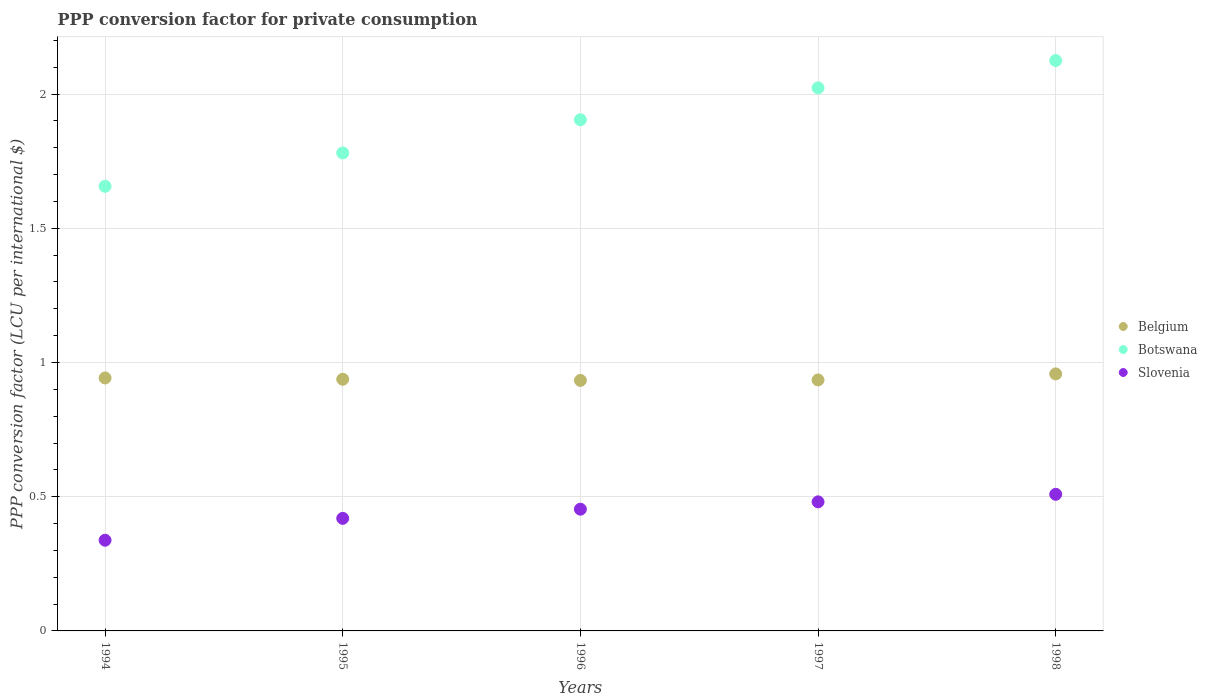How many different coloured dotlines are there?
Provide a succinct answer. 3. What is the PPP conversion factor for private consumption in Belgium in 1995?
Give a very brief answer. 0.94. Across all years, what is the maximum PPP conversion factor for private consumption in Slovenia?
Your answer should be very brief. 0.51. Across all years, what is the minimum PPP conversion factor for private consumption in Belgium?
Provide a succinct answer. 0.93. In which year was the PPP conversion factor for private consumption in Botswana maximum?
Your response must be concise. 1998. In which year was the PPP conversion factor for private consumption in Botswana minimum?
Ensure brevity in your answer.  1994. What is the total PPP conversion factor for private consumption in Botswana in the graph?
Offer a very short reply. 9.49. What is the difference between the PPP conversion factor for private consumption in Belgium in 1994 and that in 1997?
Your answer should be compact. 0.01. What is the difference between the PPP conversion factor for private consumption in Botswana in 1997 and the PPP conversion factor for private consumption in Slovenia in 1996?
Your answer should be very brief. 1.57. What is the average PPP conversion factor for private consumption in Slovenia per year?
Offer a terse response. 0.44. In the year 1996, what is the difference between the PPP conversion factor for private consumption in Belgium and PPP conversion factor for private consumption in Slovenia?
Keep it short and to the point. 0.48. In how many years, is the PPP conversion factor for private consumption in Belgium greater than 1.6 LCU?
Make the answer very short. 0. What is the ratio of the PPP conversion factor for private consumption in Belgium in 1995 to that in 1998?
Ensure brevity in your answer.  0.98. What is the difference between the highest and the second highest PPP conversion factor for private consumption in Botswana?
Offer a terse response. 0.1. What is the difference between the highest and the lowest PPP conversion factor for private consumption in Belgium?
Give a very brief answer. 0.02. In how many years, is the PPP conversion factor for private consumption in Belgium greater than the average PPP conversion factor for private consumption in Belgium taken over all years?
Offer a very short reply. 2. Is the sum of the PPP conversion factor for private consumption in Belgium in 1995 and 1996 greater than the maximum PPP conversion factor for private consumption in Slovenia across all years?
Make the answer very short. Yes. Is the PPP conversion factor for private consumption in Belgium strictly greater than the PPP conversion factor for private consumption in Slovenia over the years?
Your answer should be very brief. Yes. How many dotlines are there?
Keep it short and to the point. 3. What is the difference between two consecutive major ticks on the Y-axis?
Offer a terse response. 0.5. Are the values on the major ticks of Y-axis written in scientific E-notation?
Make the answer very short. No. Where does the legend appear in the graph?
Your answer should be very brief. Center right. How many legend labels are there?
Your answer should be very brief. 3. How are the legend labels stacked?
Your response must be concise. Vertical. What is the title of the graph?
Your response must be concise. PPP conversion factor for private consumption. What is the label or title of the X-axis?
Offer a very short reply. Years. What is the label or title of the Y-axis?
Keep it short and to the point. PPP conversion factor (LCU per international $). What is the PPP conversion factor (LCU per international $) in Belgium in 1994?
Provide a short and direct response. 0.94. What is the PPP conversion factor (LCU per international $) in Botswana in 1994?
Keep it short and to the point. 1.66. What is the PPP conversion factor (LCU per international $) of Slovenia in 1994?
Offer a very short reply. 0.34. What is the PPP conversion factor (LCU per international $) of Belgium in 1995?
Your response must be concise. 0.94. What is the PPP conversion factor (LCU per international $) in Botswana in 1995?
Make the answer very short. 1.78. What is the PPP conversion factor (LCU per international $) of Slovenia in 1995?
Offer a very short reply. 0.42. What is the PPP conversion factor (LCU per international $) of Belgium in 1996?
Provide a succinct answer. 0.93. What is the PPP conversion factor (LCU per international $) of Botswana in 1996?
Your answer should be compact. 1.9. What is the PPP conversion factor (LCU per international $) in Slovenia in 1996?
Give a very brief answer. 0.45. What is the PPP conversion factor (LCU per international $) of Belgium in 1997?
Offer a terse response. 0.94. What is the PPP conversion factor (LCU per international $) in Botswana in 1997?
Your answer should be compact. 2.02. What is the PPP conversion factor (LCU per international $) of Slovenia in 1997?
Your answer should be compact. 0.48. What is the PPP conversion factor (LCU per international $) in Belgium in 1998?
Give a very brief answer. 0.96. What is the PPP conversion factor (LCU per international $) of Botswana in 1998?
Offer a very short reply. 2.12. What is the PPP conversion factor (LCU per international $) of Slovenia in 1998?
Ensure brevity in your answer.  0.51. Across all years, what is the maximum PPP conversion factor (LCU per international $) of Belgium?
Offer a terse response. 0.96. Across all years, what is the maximum PPP conversion factor (LCU per international $) of Botswana?
Your answer should be very brief. 2.12. Across all years, what is the maximum PPP conversion factor (LCU per international $) of Slovenia?
Provide a succinct answer. 0.51. Across all years, what is the minimum PPP conversion factor (LCU per international $) in Belgium?
Your answer should be very brief. 0.93. Across all years, what is the minimum PPP conversion factor (LCU per international $) in Botswana?
Your answer should be very brief. 1.66. Across all years, what is the minimum PPP conversion factor (LCU per international $) in Slovenia?
Your response must be concise. 0.34. What is the total PPP conversion factor (LCU per international $) of Belgium in the graph?
Your answer should be compact. 4.71. What is the total PPP conversion factor (LCU per international $) in Botswana in the graph?
Offer a very short reply. 9.49. What is the total PPP conversion factor (LCU per international $) in Slovenia in the graph?
Provide a succinct answer. 2.2. What is the difference between the PPP conversion factor (LCU per international $) of Belgium in 1994 and that in 1995?
Provide a short and direct response. 0. What is the difference between the PPP conversion factor (LCU per international $) of Botswana in 1994 and that in 1995?
Your answer should be compact. -0.12. What is the difference between the PPP conversion factor (LCU per international $) of Slovenia in 1994 and that in 1995?
Ensure brevity in your answer.  -0.08. What is the difference between the PPP conversion factor (LCU per international $) of Belgium in 1994 and that in 1996?
Provide a short and direct response. 0.01. What is the difference between the PPP conversion factor (LCU per international $) of Botswana in 1994 and that in 1996?
Keep it short and to the point. -0.25. What is the difference between the PPP conversion factor (LCU per international $) of Slovenia in 1994 and that in 1996?
Make the answer very short. -0.12. What is the difference between the PPP conversion factor (LCU per international $) in Belgium in 1994 and that in 1997?
Keep it short and to the point. 0.01. What is the difference between the PPP conversion factor (LCU per international $) of Botswana in 1994 and that in 1997?
Your response must be concise. -0.37. What is the difference between the PPP conversion factor (LCU per international $) in Slovenia in 1994 and that in 1997?
Give a very brief answer. -0.14. What is the difference between the PPP conversion factor (LCU per international $) in Belgium in 1994 and that in 1998?
Offer a terse response. -0.02. What is the difference between the PPP conversion factor (LCU per international $) of Botswana in 1994 and that in 1998?
Offer a terse response. -0.47. What is the difference between the PPP conversion factor (LCU per international $) of Slovenia in 1994 and that in 1998?
Ensure brevity in your answer.  -0.17. What is the difference between the PPP conversion factor (LCU per international $) in Belgium in 1995 and that in 1996?
Give a very brief answer. 0. What is the difference between the PPP conversion factor (LCU per international $) in Botswana in 1995 and that in 1996?
Ensure brevity in your answer.  -0.12. What is the difference between the PPP conversion factor (LCU per international $) of Slovenia in 1995 and that in 1996?
Give a very brief answer. -0.03. What is the difference between the PPP conversion factor (LCU per international $) in Belgium in 1995 and that in 1997?
Your answer should be very brief. 0. What is the difference between the PPP conversion factor (LCU per international $) in Botswana in 1995 and that in 1997?
Offer a terse response. -0.24. What is the difference between the PPP conversion factor (LCU per international $) of Slovenia in 1995 and that in 1997?
Give a very brief answer. -0.06. What is the difference between the PPP conversion factor (LCU per international $) in Belgium in 1995 and that in 1998?
Your answer should be very brief. -0.02. What is the difference between the PPP conversion factor (LCU per international $) of Botswana in 1995 and that in 1998?
Give a very brief answer. -0.34. What is the difference between the PPP conversion factor (LCU per international $) of Slovenia in 1995 and that in 1998?
Make the answer very short. -0.09. What is the difference between the PPP conversion factor (LCU per international $) of Belgium in 1996 and that in 1997?
Make the answer very short. -0. What is the difference between the PPP conversion factor (LCU per international $) of Botswana in 1996 and that in 1997?
Your answer should be very brief. -0.12. What is the difference between the PPP conversion factor (LCU per international $) in Slovenia in 1996 and that in 1997?
Provide a succinct answer. -0.03. What is the difference between the PPP conversion factor (LCU per international $) in Belgium in 1996 and that in 1998?
Your answer should be very brief. -0.02. What is the difference between the PPP conversion factor (LCU per international $) of Botswana in 1996 and that in 1998?
Offer a very short reply. -0.22. What is the difference between the PPP conversion factor (LCU per international $) in Slovenia in 1996 and that in 1998?
Keep it short and to the point. -0.06. What is the difference between the PPP conversion factor (LCU per international $) of Belgium in 1997 and that in 1998?
Provide a succinct answer. -0.02. What is the difference between the PPP conversion factor (LCU per international $) in Botswana in 1997 and that in 1998?
Your response must be concise. -0.1. What is the difference between the PPP conversion factor (LCU per international $) of Slovenia in 1997 and that in 1998?
Your response must be concise. -0.03. What is the difference between the PPP conversion factor (LCU per international $) in Belgium in 1994 and the PPP conversion factor (LCU per international $) in Botswana in 1995?
Provide a succinct answer. -0.84. What is the difference between the PPP conversion factor (LCU per international $) in Belgium in 1994 and the PPP conversion factor (LCU per international $) in Slovenia in 1995?
Provide a short and direct response. 0.52. What is the difference between the PPP conversion factor (LCU per international $) in Botswana in 1994 and the PPP conversion factor (LCU per international $) in Slovenia in 1995?
Offer a very short reply. 1.24. What is the difference between the PPP conversion factor (LCU per international $) of Belgium in 1994 and the PPP conversion factor (LCU per international $) of Botswana in 1996?
Offer a terse response. -0.96. What is the difference between the PPP conversion factor (LCU per international $) in Belgium in 1994 and the PPP conversion factor (LCU per international $) in Slovenia in 1996?
Provide a short and direct response. 0.49. What is the difference between the PPP conversion factor (LCU per international $) of Botswana in 1994 and the PPP conversion factor (LCU per international $) of Slovenia in 1996?
Provide a succinct answer. 1.2. What is the difference between the PPP conversion factor (LCU per international $) in Belgium in 1994 and the PPP conversion factor (LCU per international $) in Botswana in 1997?
Your response must be concise. -1.08. What is the difference between the PPP conversion factor (LCU per international $) of Belgium in 1994 and the PPP conversion factor (LCU per international $) of Slovenia in 1997?
Give a very brief answer. 0.46. What is the difference between the PPP conversion factor (LCU per international $) of Botswana in 1994 and the PPP conversion factor (LCU per international $) of Slovenia in 1997?
Offer a very short reply. 1.18. What is the difference between the PPP conversion factor (LCU per international $) of Belgium in 1994 and the PPP conversion factor (LCU per international $) of Botswana in 1998?
Ensure brevity in your answer.  -1.18. What is the difference between the PPP conversion factor (LCU per international $) of Belgium in 1994 and the PPP conversion factor (LCU per international $) of Slovenia in 1998?
Provide a succinct answer. 0.43. What is the difference between the PPP conversion factor (LCU per international $) of Botswana in 1994 and the PPP conversion factor (LCU per international $) of Slovenia in 1998?
Ensure brevity in your answer.  1.15. What is the difference between the PPP conversion factor (LCU per international $) in Belgium in 1995 and the PPP conversion factor (LCU per international $) in Botswana in 1996?
Offer a terse response. -0.97. What is the difference between the PPP conversion factor (LCU per international $) of Belgium in 1995 and the PPP conversion factor (LCU per international $) of Slovenia in 1996?
Make the answer very short. 0.48. What is the difference between the PPP conversion factor (LCU per international $) in Botswana in 1995 and the PPP conversion factor (LCU per international $) in Slovenia in 1996?
Offer a terse response. 1.33. What is the difference between the PPP conversion factor (LCU per international $) in Belgium in 1995 and the PPP conversion factor (LCU per international $) in Botswana in 1997?
Give a very brief answer. -1.09. What is the difference between the PPP conversion factor (LCU per international $) in Belgium in 1995 and the PPP conversion factor (LCU per international $) in Slovenia in 1997?
Give a very brief answer. 0.46. What is the difference between the PPP conversion factor (LCU per international $) in Botswana in 1995 and the PPP conversion factor (LCU per international $) in Slovenia in 1997?
Your response must be concise. 1.3. What is the difference between the PPP conversion factor (LCU per international $) in Belgium in 1995 and the PPP conversion factor (LCU per international $) in Botswana in 1998?
Your answer should be compact. -1.19. What is the difference between the PPP conversion factor (LCU per international $) of Belgium in 1995 and the PPP conversion factor (LCU per international $) of Slovenia in 1998?
Ensure brevity in your answer.  0.43. What is the difference between the PPP conversion factor (LCU per international $) in Botswana in 1995 and the PPP conversion factor (LCU per international $) in Slovenia in 1998?
Offer a very short reply. 1.27. What is the difference between the PPP conversion factor (LCU per international $) of Belgium in 1996 and the PPP conversion factor (LCU per international $) of Botswana in 1997?
Provide a short and direct response. -1.09. What is the difference between the PPP conversion factor (LCU per international $) of Belgium in 1996 and the PPP conversion factor (LCU per international $) of Slovenia in 1997?
Offer a terse response. 0.45. What is the difference between the PPP conversion factor (LCU per international $) in Botswana in 1996 and the PPP conversion factor (LCU per international $) in Slovenia in 1997?
Keep it short and to the point. 1.42. What is the difference between the PPP conversion factor (LCU per international $) in Belgium in 1996 and the PPP conversion factor (LCU per international $) in Botswana in 1998?
Make the answer very short. -1.19. What is the difference between the PPP conversion factor (LCU per international $) of Belgium in 1996 and the PPP conversion factor (LCU per international $) of Slovenia in 1998?
Ensure brevity in your answer.  0.42. What is the difference between the PPP conversion factor (LCU per international $) of Botswana in 1996 and the PPP conversion factor (LCU per international $) of Slovenia in 1998?
Ensure brevity in your answer.  1.4. What is the difference between the PPP conversion factor (LCU per international $) of Belgium in 1997 and the PPP conversion factor (LCU per international $) of Botswana in 1998?
Keep it short and to the point. -1.19. What is the difference between the PPP conversion factor (LCU per international $) in Belgium in 1997 and the PPP conversion factor (LCU per international $) in Slovenia in 1998?
Ensure brevity in your answer.  0.43. What is the difference between the PPP conversion factor (LCU per international $) in Botswana in 1997 and the PPP conversion factor (LCU per international $) in Slovenia in 1998?
Your response must be concise. 1.51. What is the average PPP conversion factor (LCU per international $) in Belgium per year?
Your answer should be compact. 0.94. What is the average PPP conversion factor (LCU per international $) of Botswana per year?
Your answer should be compact. 1.9. What is the average PPP conversion factor (LCU per international $) in Slovenia per year?
Your answer should be very brief. 0.44. In the year 1994, what is the difference between the PPP conversion factor (LCU per international $) in Belgium and PPP conversion factor (LCU per international $) in Botswana?
Your answer should be very brief. -0.71. In the year 1994, what is the difference between the PPP conversion factor (LCU per international $) in Belgium and PPP conversion factor (LCU per international $) in Slovenia?
Keep it short and to the point. 0.6. In the year 1994, what is the difference between the PPP conversion factor (LCU per international $) of Botswana and PPP conversion factor (LCU per international $) of Slovenia?
Provide a short and direct response. 1.32. In the year 1995, what is the difference between the PPP conversion factor (LCU per international $) of Belgium and PPP conversion factor (LCU per international $) of Botswana?
Keep it short and to the point. -0.84. In the year 1995, what is the difference between the PPP conversion factor (LCU per international $) in Belgium and PPP conversion factor (LCU per international $) in Slovenia?
Your answer should be very brief. 0.52. In the year 1995, what is the difference between the PPP conversion factor (LCU per international $) in Botswana and PPP conversion factor (LCU per international $) in Slovenia?
Provide a succinct answer. 1.36. In the year 1996, what is the difference between the PPP conversion factor (LCU per international $) in Belgium and PPP conversion factor (LCU per international $) in Botswana?
Offer a terse response. -0.97. In the year 1996, what is the difference between the PPP conversion factor (LCU per international $) in Belgium and PPP conversion factor (LCU per international $) in Slovenia?
Ensure brevity in your answer.  0.48. In the year 1996, what is the difference between the PPP conversion factor (LCU per international $) in Botswana and PPP conversion factor (LCU per international $) in Slovenia?
Offer a very short reply. 1.45. In the year 1997, what is the difference between the PPP conversion factor (LCU per international $) of Belgium and PPP conversion factor (LCU per international $) of Botswana?
Provide a succinct answer. -1.09. In the year 1997, what is the difference between the PPP conversion factor (LCU per international $) in Belgium and PPP conversion factor (LCU per international $) in Slovenia?
Offer a terse response. 0.45. In the year 1997, what is the difference between the PPP conversion factor (LCU per international $) of Botswana and PPP conversion factor (LCU per international $) of Slovenia?
Your answer should be very brief. 1.54. In the year 1998, what is the difference between the PPP conversion factor (LCU per international $) in Belgium and PPP conversion factor (LCU per international $) in Botswana?
Your answer should be very brief. -1.17. In the year 1998, what is the difference between the PPP conversion factor (LCU per international $) in Belgium and PPP conversion factor (LCU per international $) in Slovenia?
Give a very brief answer. 0.45. In the year 1998, what is the difference between the PPP conversion factor (LCU per international $) of Botswana and PPP conversion factor (LCU per international $) of Slovenia?
Offer a very short reply. 1.62. What is the ratio of the PPP conversion factor (LCU per international $) of Botswana in 1994 to that in 1995?
Provide a succinct answer. 0.93. What is the ratio of the PPP conversion factor (LCU per international $) of Slovenia in 1994 to that in 1995?
Your answer should be very brief. 0.81. What is the ratio of the PPP conversion factor (LCU per international $) of Belgium in 1994 to that in 1996?
Provide a succinct answer. 1.01. What is the ratio of the PPP conversion factor (LCU per international $) of Botswana in 1994 to that in 1996?
Provide a succinct answer. 0.87. What is the ratio of the PPP conversion factor (LCU per international $) in Slovenia in 1994 to that in 1996?
Offer a terse response. 0.74. What is the ratio of the PPP conversion factor (LCU per international $) in Belgium in 1994 to that in 1997?
Keep it short and to the point. 1.01. What is the ratio of the PPP conversion factor (LCU per international $) of Botswana in 1994 to that in 1997?
Keep it short and to the point. 0.82. What is the ratio of the PPP conversion factor (LCU per international $) in Slovenia in 1994 to that in 1997?
Offer a terse response. 0.7. What is the ratio of the PPP conversion factor (LCU per international $) in Belgium in 1994 to that in 1998?
Provide a short and direct response. 0.98. What is the ratio of the PPP conversion factor (LCU per international $) of Botswana in 1994 to that in 1998?
Your answer should be very brief. 0.78. What is the ratio of the PPP conversion factor (LCU per international $) of Slovenia in 1994 to that in 1998?
Provide a short and direct response. 0.66. What is the ratio of the PPP conversion factor (LCU per international $) of Botswana in 1995 to that in 1996?
Ensure brevity in your answer.  0.94. What is the ratio of the PPP conversion factor (LCU per international $) in Slovenia in 1995 to that in 1996?
Give a very brief answer. 0.92. What is the ratio of the PPP conversion factor (LCU per international $) in Botswana in 1995 to that in 1997?
Your answer should be compact. 0.88. What is the ratio of the PPP conversion factor (LCU per international $) of Slovenia in 1995 to that in 1997?
Your response must be concise. 0.87. What is the ratio of the PPP conversion factor (LCU per international $) of Belgium in 1995 to that in 1998?
Keep it short and to the point. 0.98. What is the ratio of the PPP conversion factor (LCU per international $) in Botswana in 1995 to that in 1998?
Your answer should be compact. 0.84. What is the ratio of the PPP conversion factor (LCU per international $) of Slovenia in 1995 to that in 1998?
Offer a very short reply. 0.82. What is the ratio of the PPP conversion factor (LCU per international $) in Botswana in 1996 to that in 1997?
Make the answer very short. 0.94. What is the ratio of the PPP conversion factor (LCU per international $) of Slovenia in 1996 to that in 1997?
Your response must be concise. 0.94. What is the ratio of the PPP conversion factor (LCU per international $) of Belgium in 1996 to that in 1998?
Make the answer very short. 0.97. What is the ratio of the PPP conversion factor (LCU per international $) of Botswana in 1996 to that in 1998?
Offer a very short reply. 0.9. What is the ratio of the PPP conversion factor (LCU per international $) of Slovenia in 1996 to that in 1998?
Provide a succinct answer. 0.89. What is the ratio of the PPP conversion factor (LCU per international $) of Belgium in 1997 to that in 1998?
Give a very brief answer. 0.98. What is the ratio of the PPP conversion factor (LCU per international $) in Botswana in 1997 to that in 1998?
Provide a short and direct response. 0.95. What is the ratio of the PPP conversion factor (LCU per international $) of Slovenia in 1997 to that in 1998?
Offer a very short reply. 0.94. What is the difference between the highest and the second highest PPP conversion factor (LCU per international $) in Belgium?
Make the answer very short. 0.02. What is the difference between the highest and the second highest PPP conversion factor (LCU per international $) in Botswana?
Offer a very short reply. 0.1. What is the difference between the highest and the second highest PPP conversion factor (LCU per international $) of Slovenia?
Your answer should be compact. 0.03. What is the difference between the highest and the lowest PPP conversion factor (LCU per international $) of Belgium?
Ensure brevity in your answer.  0.02. What is the difference between the highest and the lowest PPP conversion factor (LCU per international $) of Botswana?
Offer a very short reply. 0.47. What is the difference between the highest and the lowest PPP conversion factor (LCU per international $) in Slovenia?
Provide a short and direct response. 0.17. 